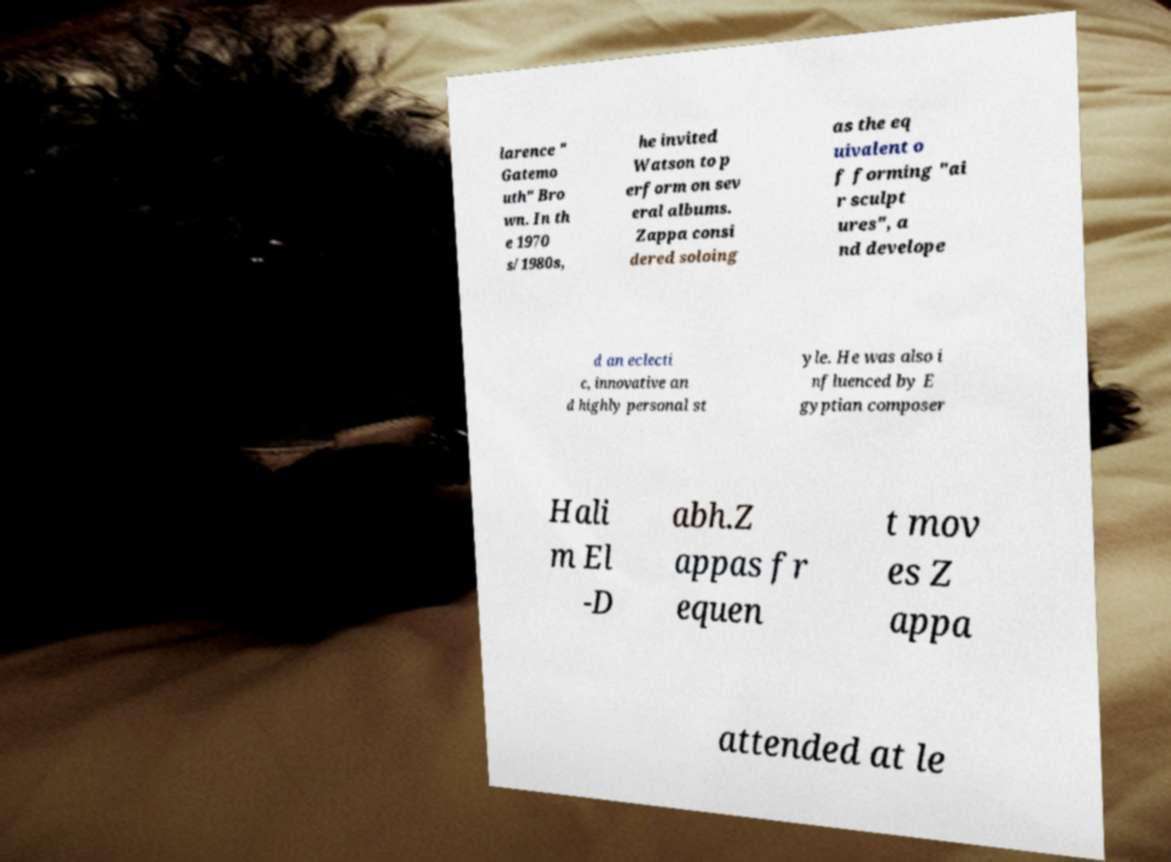Please read and relay the text visible in this image. What does it say? larence " Gatemo uth" Bro wn. In th e 1970 s/1980s, he invited Watson to p erform on sev eral albums. Zappa consi dered soloing as the eq uivalent o f forming "ai r sculpt ures", a nd develope d an eclecti c, innovative an d highly personal st yle. He was also i nfluenced by E gyptian composer Hali m El -D abh.Z appas fr equen t mov es Z appa attended at le 